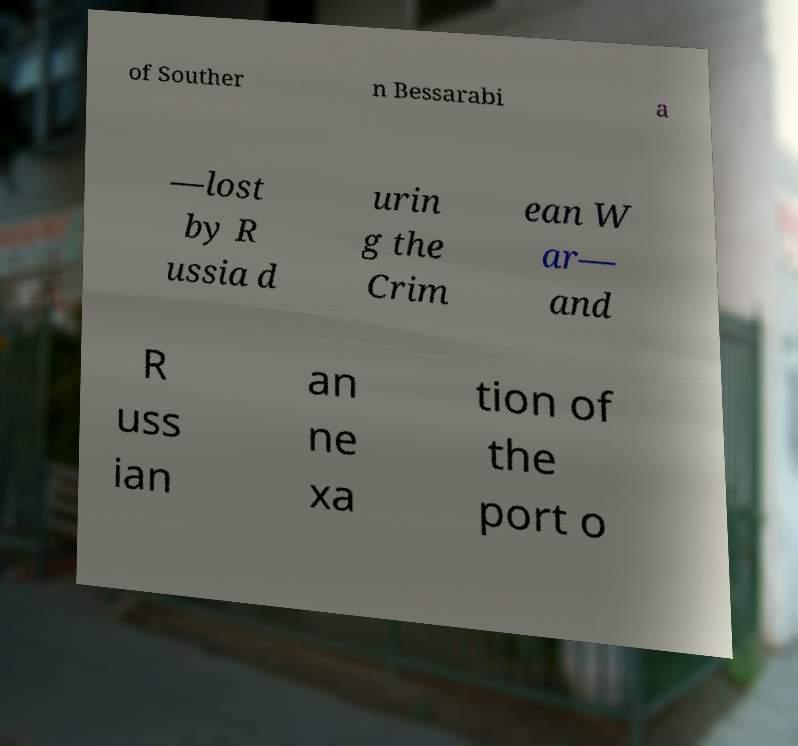Please read and relay the text visible in this image. What does it say? of Souther n Bessarabi a —lost by R ussia d urin g the Crim ean W ar— and R uss ian an ne xa tion of the port o 